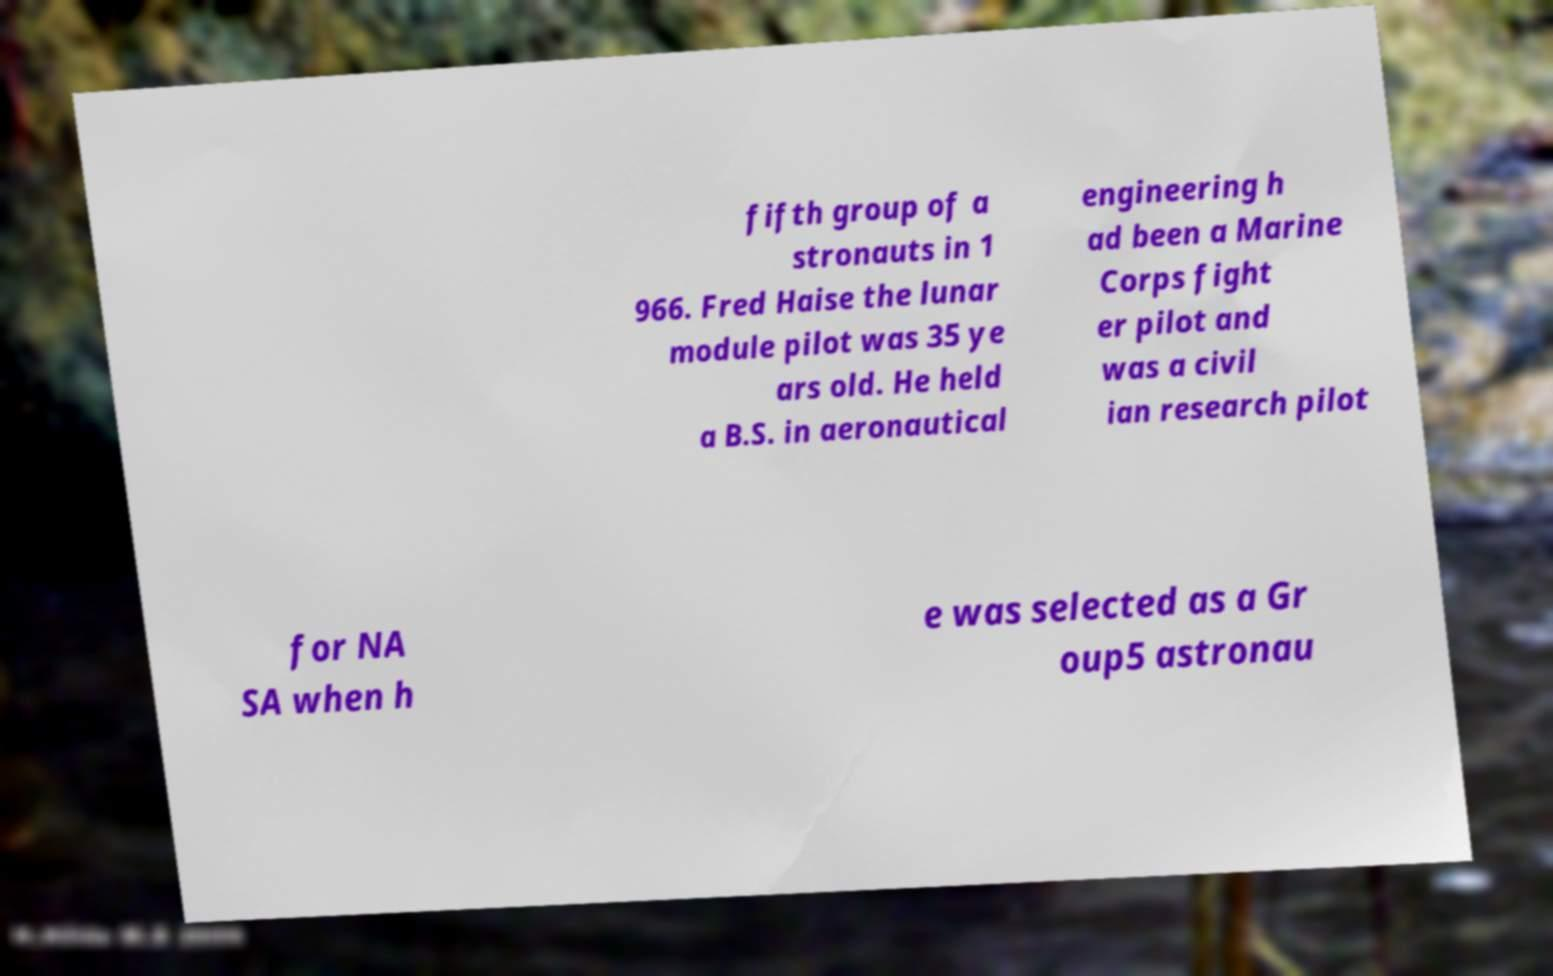Could you extract and type out the text from this image? fifth group of a stronauts in 1 966. Fred Haise the lunar module pilot was 35 ye ars old. He held a B.S. in aeronautical engineering h ad been a Marine Corps fight er pilot and was a civil ian research pilot for NA SA when h e was selected as a Gr oup5 astronau 